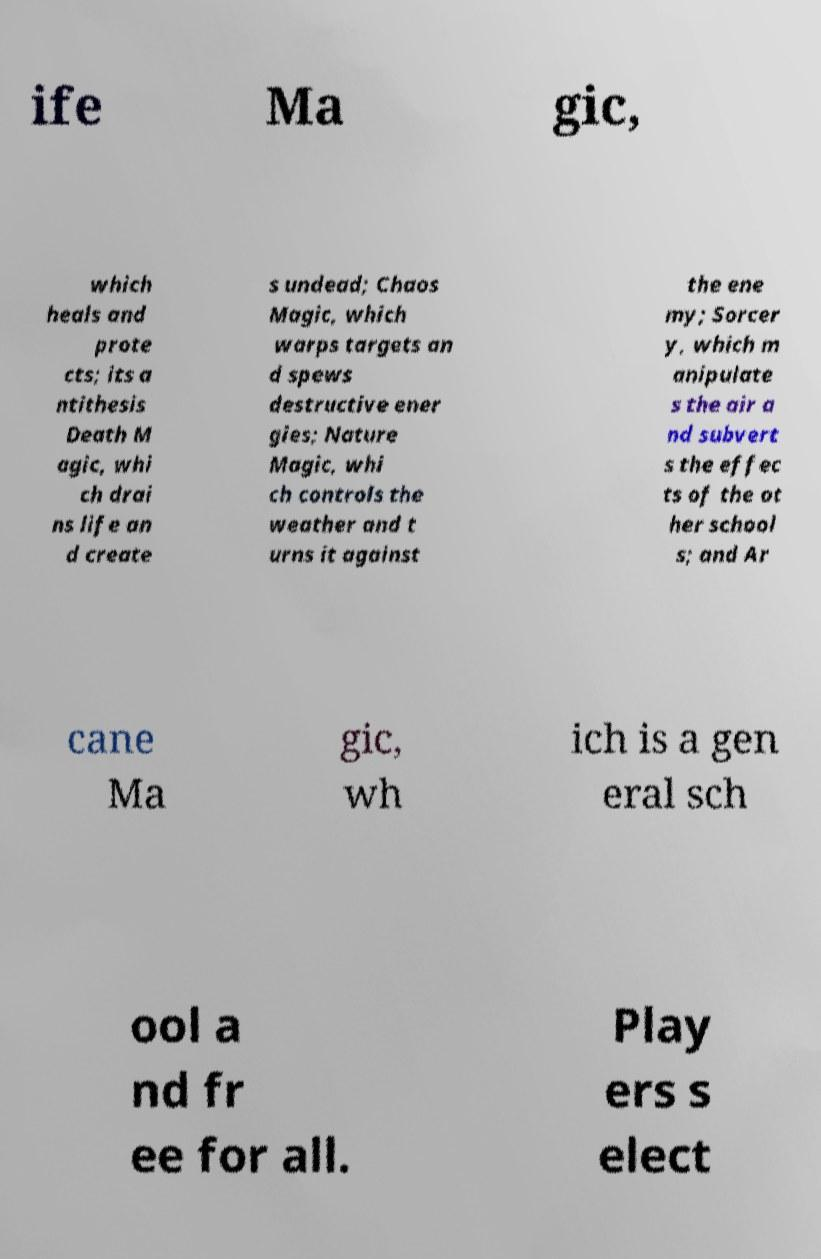Please identify and transcribe the text found in this image. ife Ma gic, which heals and prote cts; its a ntithesis Death M agic, whi ch drai ns life an d create s undead; Chaos Magic, which warps targets an d spews destructive ener gies; Nature Magic, whi ch controls the weather and t urns it against the ene my; Sorcer y, which m anipulate s the air a nd subvert s the effec ts of the ot her school s; and Ar cane Ma gic, wh ich is a gen eral sch ool a nd fr ee for all. Play ers s elect 